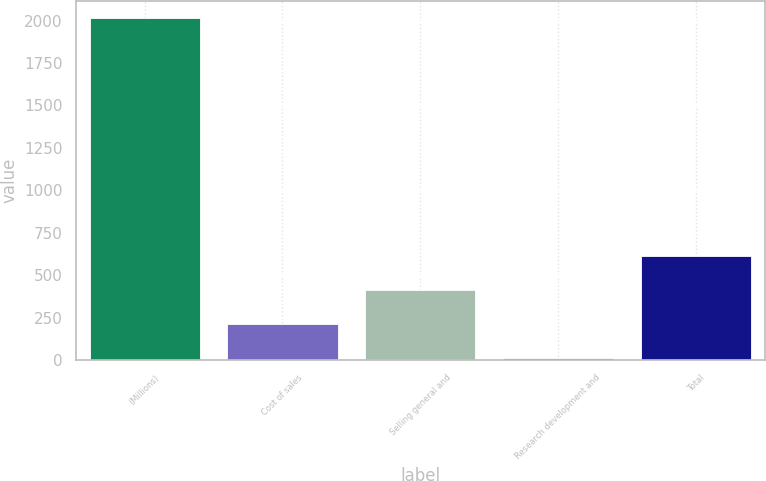<chart> <loc_0><loc_0><loc_500><loc_500><bar_chart><fcel>(Millions)<fcel>Cost of sales<fcel>Selling general and<fcel>Research development and<fcel>Total<nl><fcel>2015<fcel>212.3<fcel>412.6<fcel>12<fcel>612.9<nl></chart> 